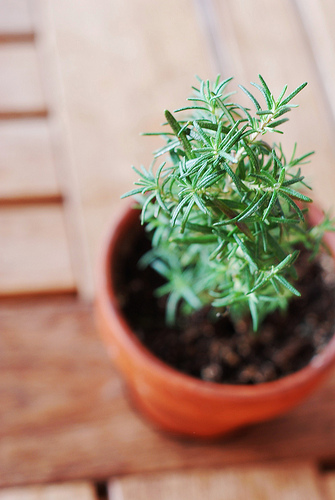<image>
Can you confirm if the plant is behind the dirt? No. The plant is not behind the dirt. From this viewpoint, the plant appears to be positioned elsewhere in the scene. 